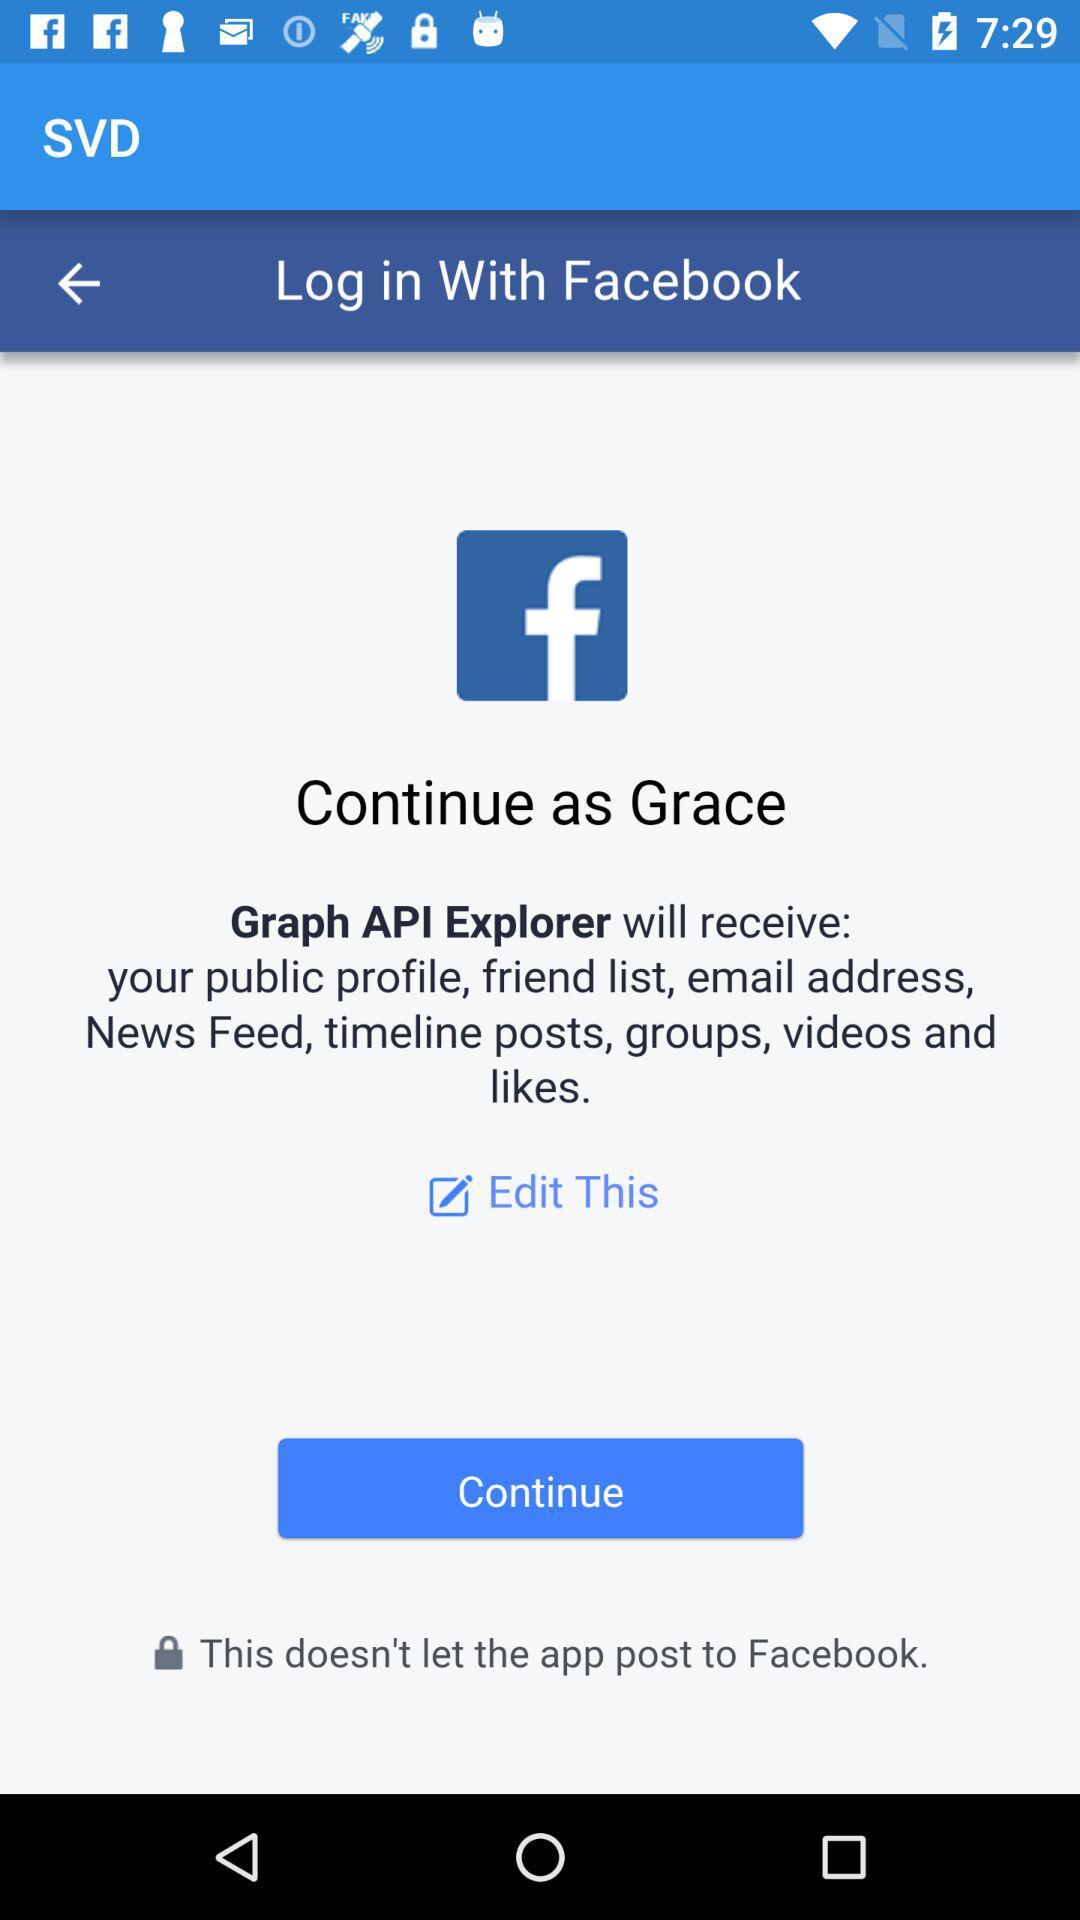Which information will the "Graph API Explorer" receive? The "Graph API Explorer" will receive the public profile, friend list, email address, news feed, timeline posts, groups, videos and likes. 